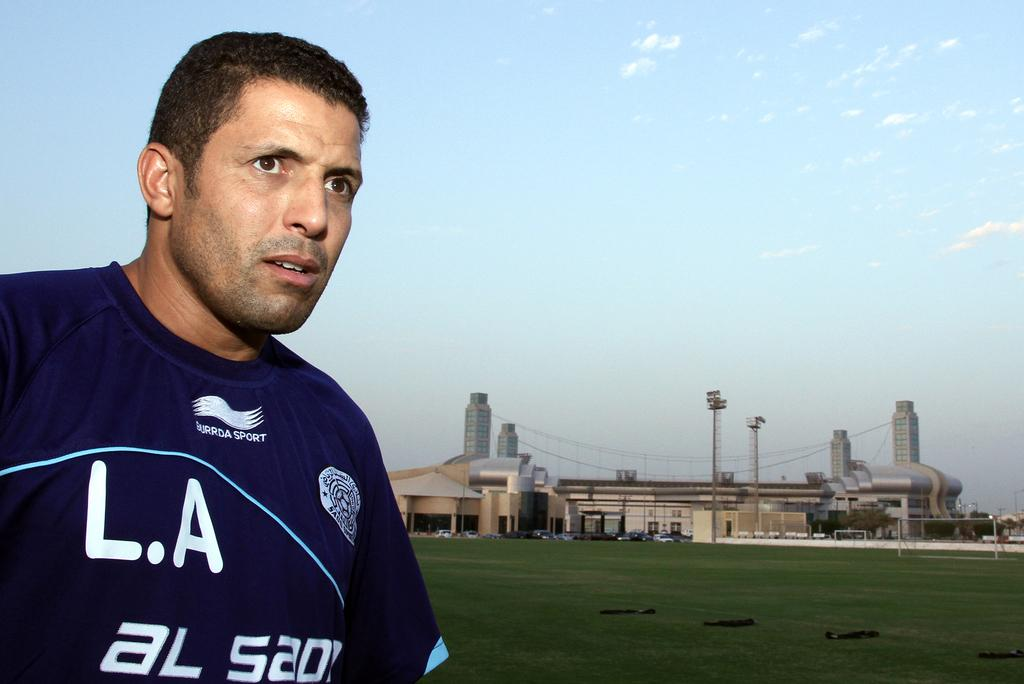Provide a one-sentence caption for the provided image. a person in a LA AL 520 jersey looking over a field. 